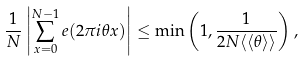Convert formula to latex. <formula><loc_0><loc_0><loc_500><loc_500>\frac { 1 } { N } \left | \sum _ { x = 0 } ^ { N - 1 } e ( 2 \pi i \theta x ) \right | \leq \min \left ( 1 , \frac { 1 } { 2 N \langle \langle \theta \rangle \rangle } \right ) ,</formula> 